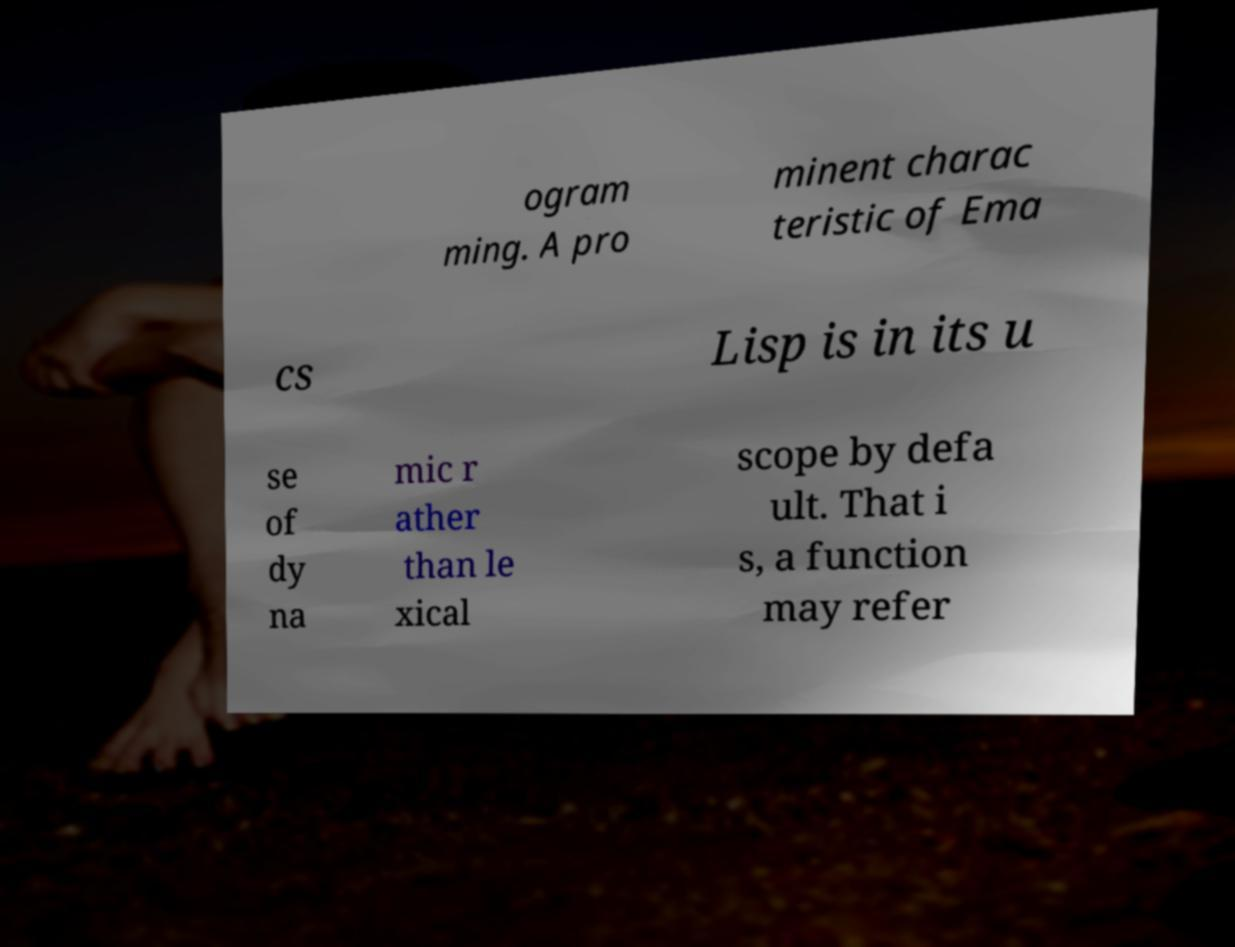There's text embedded in this image that I need extracted. Can you transcribe it verbatim? ogram ming. A pro minent charac teristic of Ema cs Lisp is in its u se of dy na mic r ather than le xical scope by defa ult. That i s, a function may refer 